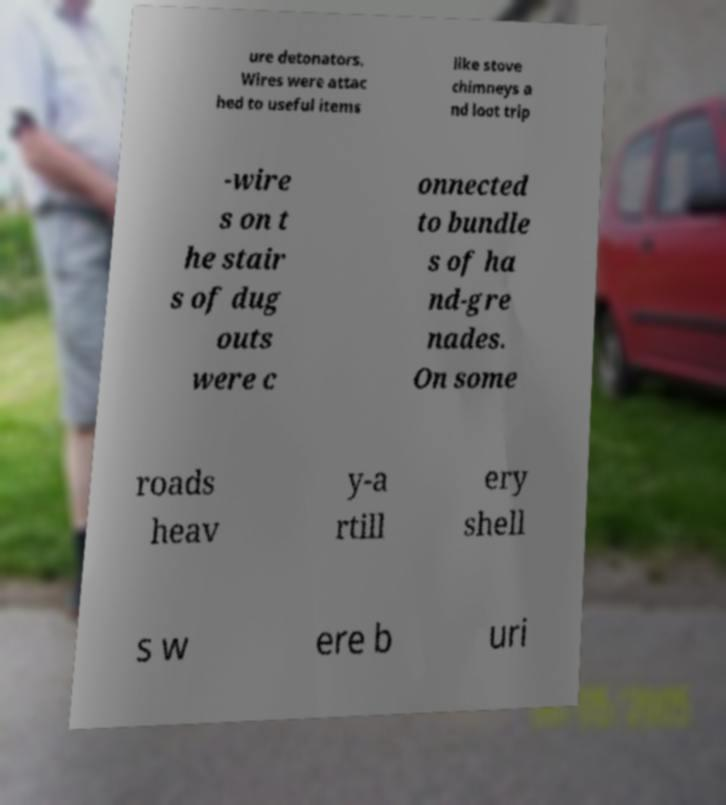For documentation purposes, I need the text within this image transcribed. Could you provide that? ure detonators. Wires were attac hed to useful items like stove chimneys a nd loot trip -wire s on t he stair s of dug outs were c onnected to bundle s of ha nd-gre nades. On some roads heav y-a rtill ery shell s w ere b uri 